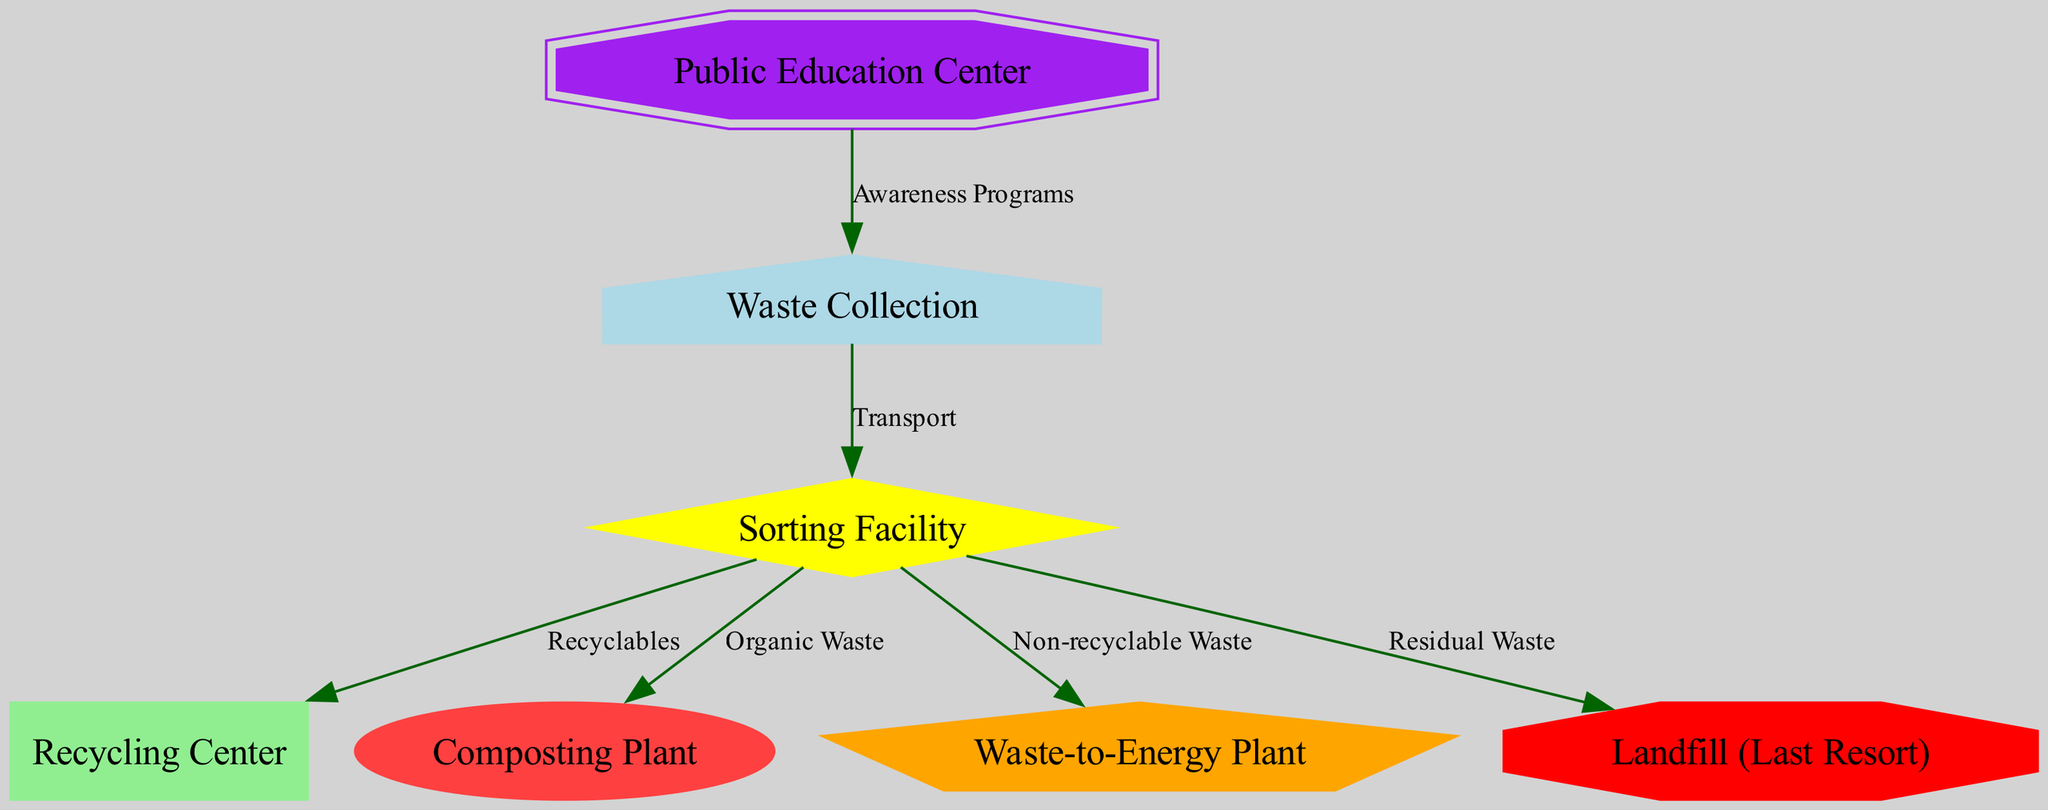What is the first step in the waste management system? The first step in the diagram is "Waste Collection," which is represented as the starting node. This node does not have any incoming edges, indicating that it initiates the process.
Answer: Waste Collection How many nodes are there in the diagram? By counting each unique node listed, we find that there are a total of 7 nodes, each representing a specific component of the waste management system.
Answer: 7 What is the last resort for waste disposal in this system? In the diagram, the "Landfill (Last Resort)" node is specifically labeled as the final option for waste management. It receives flow from the "Sorting Facility" for residual waste.
Answer: Landfill (Last Resort) Which facility processes organic waste? The diagram indicates that "Composting Plant" is the designated facility for handling organic waste, specifically indicated by an outgoing edge labeled "Organic Waste" from the "Sorting Facility."
Answer: Composting Plant What percentage of waste ideally goes to the Recycling Center based on the flow from the Sorting Facility? The flow indicates that a portion of the waste is routed from "Sorting Facility" to "Recycling Center" through the edge labeled "Recyclables." However, without numerical data in the diagram, an exact percentage cannot be determined.
Answer: Not specified What does the Public Education Center do in this diagram? The "Public Education Center" is connected to the "Waste Collection" node, indicating that it plays a role in raising awareness and educating the public about waste collection practices through "Awareness Programs."
Answer: Awareness Programs What type of waste is directed to the Waste-to-Energy Plant? According to the diagram, the edge labeled "Non-recyclable Waste" directs waste from the "Sorting Facility" to the "Waste-to-Energy Plant," clearly indicating what type of waste this facility processes.
Answer: Non-recyclable Waste Which node receives waste that cannot be recycled or composted? The "Landfill (Last Resort)" is where waste that cannot be recycled or composted ultimately ends up, as shown by its connection through the "Residual Waste" edge from the "Sorting Facility."
Answer: Landfill (Last Resort) How many edges are there in the diagram? By enumerating each connection between nodes, we find that there are a total of 6 edges directing the flow of waste between the various facilities in the diagram.
Answer: 6 